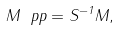<formula> <loc_0><loc_0><loc_500><loc_500>M _ { \ } p p = S ^ { - 1 } M ,</formula> 